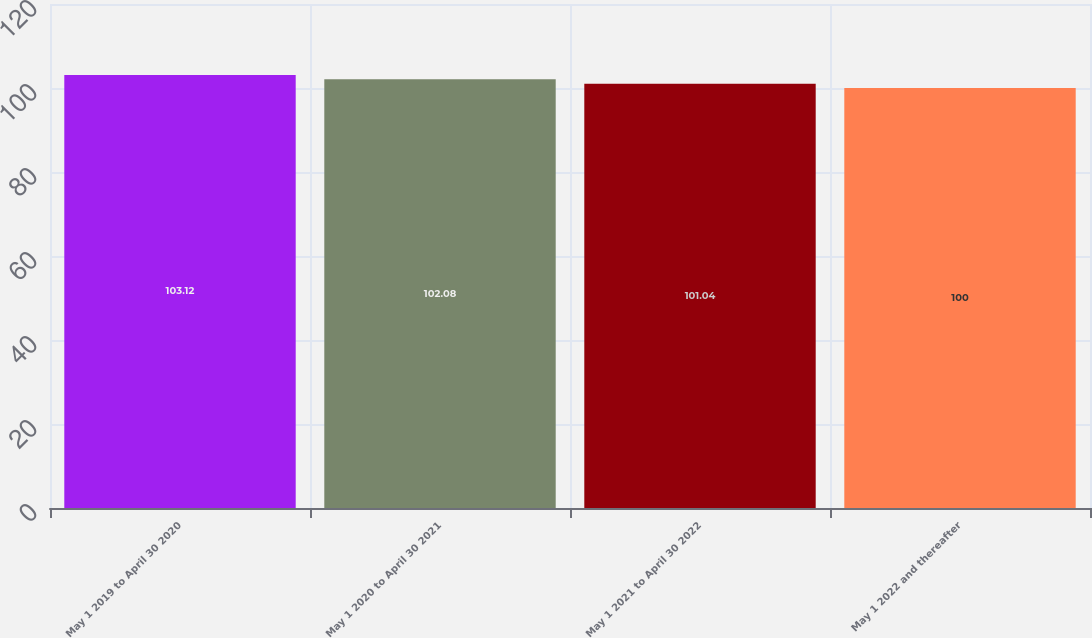<chart> <loc_0><loc_0><loc_500><loc_500><bar_chart><fcel>May 1 2019 to April 30 2020<fcel>May 1 2020 to April 30 2021<fcel>May 1 2021 to April 30 2022<fcel>May 1 2022 and thereafter<nl><fcel>103.12<fcel>102.08<fcel>101.04<fcel>100<nl></chart> 